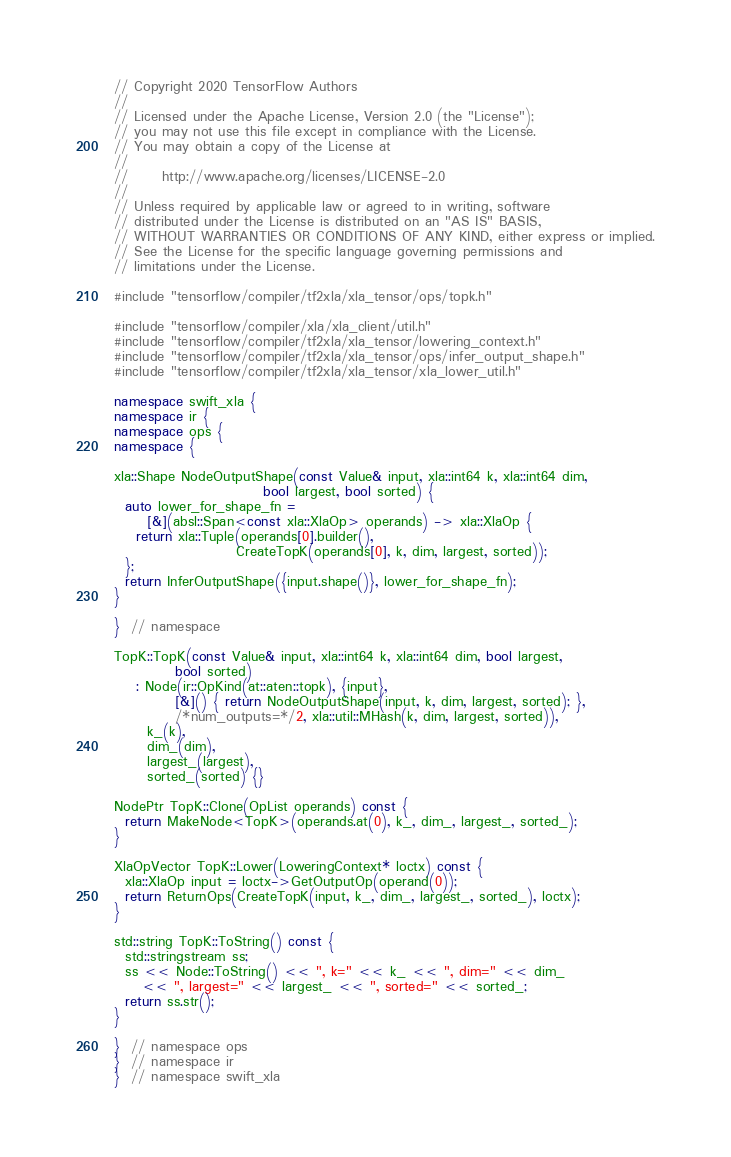Convert code to text. <code><loc_0><loc_0><loc_500><loc_500><_C++_>// Copyright 2020 TensorFlow Authors
//
// Licensed under the Apache License, Version 2.0 (the "License");
// you may not use this file except in compliance with the License.
// You may obtain a copy of the License at
//
//      http://www.apache.org/licenses/LICENSE-2.0
//
// Unless required by applicable law or agreed to in writing, software
// distributed under the License is distributed on an "AS IS" BASIS,
// WITHOUT WARRANTIES OR CONDITIONS OF ANY KIND, either express or implied.
// See the License for the specific language governing permissions and
// limitations under the License.

#include "tensorflow/compiler/tf2xla/xla_tensor/ops/topk.h"

#include "tensorflow/compiler/xla/xla_client/util.h"
#include "tensorflow/compiler/tf2xla/xla_tensor/lowering_context.h"
#include "tensorflow/compiler/tf2xla/xla_tensor/ops/infer_output_shape.h"
#include "tensorflow/compiler/tf2xla/xla_tensor/xla_lower_util.h"

namespace swift_xla {
namespace ir {
namespace ops {
namespace {

xla::Shape NodeOutputShape(const Value& input, xla::int64 k, xla::int64 dim,
                           bool largest, bool sorted) {
  auto lower_for_shape_fn =
      [&](absl::Span<const xla::XlaOp> operands) -> xla::XlaOp {
    return xla::Tuple(operands[0].builder(),
                      CreateTopK(operands[0], k, dim, largest, sorted));
  };
  return InferOutputShape({input.shape()}, lower_for_shape_fn);
}

}  // namespace

TopK::TopK(const Value& input, xla::int64 k, xla::int64 dim, bool largest,
           bool sorted)
    : Node(ir::OpKind(at::aten::topk), {input},
           [&]() { return NodeOutputShape(input, k, dim, largest, sorted); },
           /*num_outputs=*/2, xla::util::MHash(k, dim, largest, sorted)),
      k_(k),
      dim_(dim),
      largest_(largest),
      sorted_(sorted) {}

NodePtr TopK::Clone(OpList operands) const {
  return MakeNode<TopK>(operands.at(0), k_, dim_, largest_, sorted_);
}

XlaOpVector TopK::Lower(LoweringContext* loctx) const {
  xla::XlaOp input = loctx->GetOutputOp(operand(0));
  return ReturnOps(CreateTopK(input, k_, dim_, largest_, sorted_), loctx);
}

std::string TopK::ToString() const {
  std::stringstream ss;
  ss << Node::ToString() << ", k=" << k_ << ", dim=" << dim_
     << ", largest=" << largest_ << ", sorted=" << sorted_;
  return ss.str();
}

}  // namespace ops
}  // namespace ir
}  // namespace swift_xla
</code> 